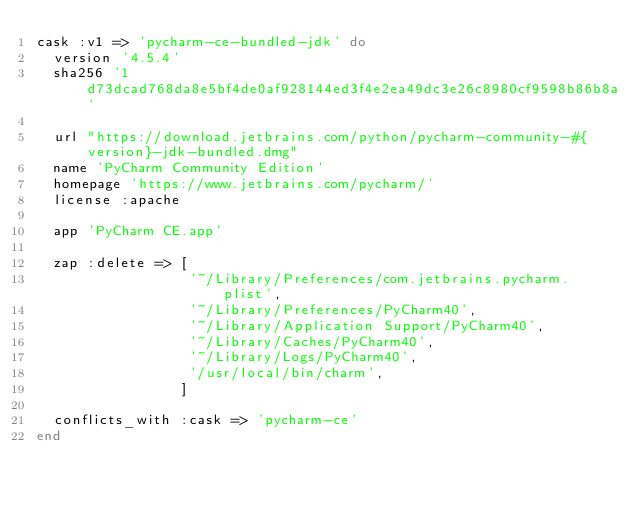Convert code to text. <code><loc_0><loc_0><loc_500><loc_500><_Ruby_>cask :v1 => 'pycharm-ce-bundled-jdk' do
  version '4.5.4'
  sha256 '1d73dcad768da8e5bf4de0af928144ed3f4e2ea49dc3e26c8980cf9598b86b8a'

  url "https://download.jetbrains.com/python/pycharm-community-#{version}-jdk-bundled.dmg"
  name 'PyCharm Community Edition'
  homepage 'https://www.jetbrains.com/pycharm/'
  license :apache

  app 'PyCharm CE.app'

  zap :delete => [
                  '~/Library/Preferences/com.jetbrains.pycharm.plist',
                  '~/Library/Preferences/PyCharm40',
                  '~/Library/Application Support/PyCharm40',
                  '~/Library/Caches/PyCharm40',
                  '~/Library/Logs/PyCharm40',
                  '/usr/local/bin/charm',
                 ]

  conflicts_with :cask => 'pycharm-ce'
end
</code> 